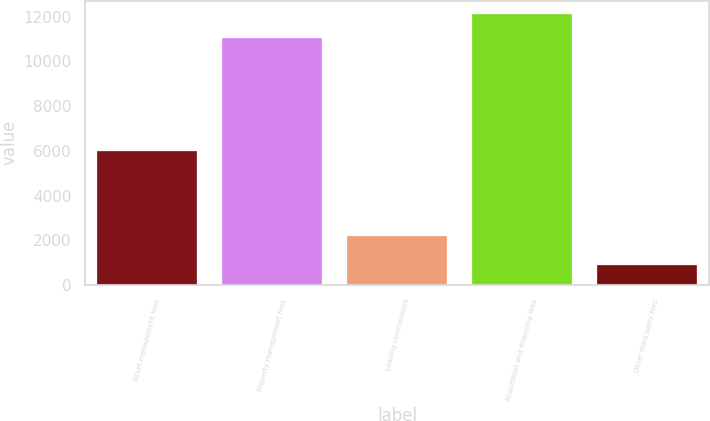Convert chart to OTSL. <chart><loc_0><loc_0><loc_500><loc_500><bar_chart><fcel>Asset management fees<fcel>Property management fees<fcel>Leasing commissions<fcel>Acquisition and financing fees<fcel>Other third party fees<nl><fcel>5977<fcel>11041<fcel>2210<fcel>12119.9<fcel>894<nl></chart> 